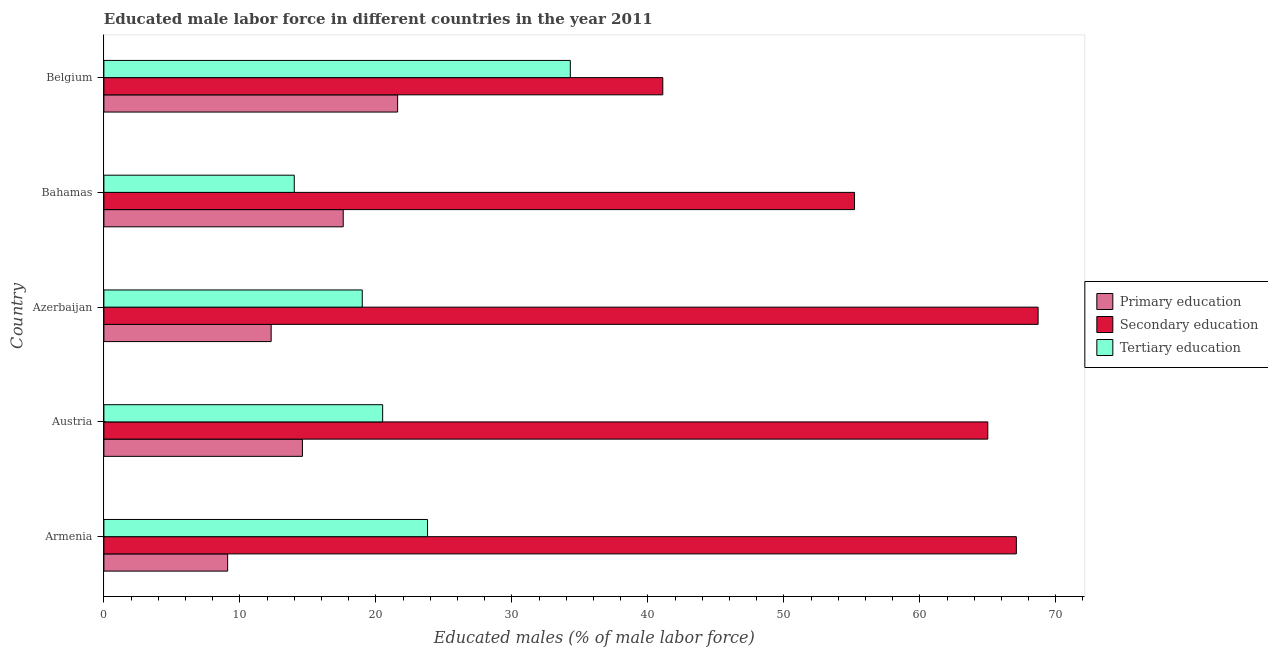How many different coloured bars are there?
Your answer should be very brief. 3. Are the number of bars on each tick of the Y-axis equal?
Ensure brevity in your answer.  Yes. How many bars are there on the 4th tick from the top?
Your response must be concise. 3. What is the label of the 4th group of bars from the top?
Offer a terse response. Austria. What is the percentage of male labor force who received primary education in Azerbaijan?
Offer a terse response. 12.3. Across all countries, what is the maximum percentage of male labor force who received primary education?
Provide a succinct answer. 21.6. Across all countries, what is the minimum percentage of male labor force who received tertiary education?
Offer a very short reply. 14. In which country was the percentage of male labor force who received secondary education minimum?
Offer a terse response. Belgium. What is the total percentage of male labor force who received tertiary education in the graph?
Your answer should be compact. 111.6. What is the difference between the percentage of male labor force who received secondary education in Bahamas and that in Belgium?
Make the answer very short. 14.1. What is the difference between the percentage of male labor force who received secondary education in Austria and the percentage of male labor force who received tertiary education in Armenia?
Keep it short and to the point. 41.2. What is the average percentage of male labor force who received primary education per country?
Ensure brevity in your answer.  15.04. What is the difference between the percentage of male labor force who received primary education and percentage of male labor force who received tertiary education in Austria?
Your answer should be compact. -5.9. What is the ratio of the percentage of male labor force who received primary education in Azerbaijan to that in Bahamas?
Offer a very short reply. 0.7. Is the difference between the percentage of male labor force who received secondary education in Austria and Belgium greater than the difference between the percentage of male labor force who received primary education in Austria and Belgium?
Offer a very short reply. Yes. What is the difference between the highest and the second highest percentage of male labor force who received primary education?
Provide a succinct answer. 4. What is the difference between the highest and the lowest percentage of male labor force who received primary education?
Ensure brevity in your answer.  12.5. In how many countries, is the percentage of male labor force who received tertiary education greater than the average percentage of male labor force who received tertiary education taken over all countries?
Ensure brevity in your answer.  2. Is the sum of the percentage of male labor force who received secondary education in Azerbaijan and Belgium greater than the maximum percentage of male labor force who received tertiary education across all countries?
Your answer should be compact. Yes. What does the 1st bar from the top in Azerbaijan represents?
Ensure brevity in your answer.  Tertiary education. What does the 3rd bar from the bottom in Armenia represents?
Give a very brief answer. Tertiary education. How many countries are there in the graph?
Your answer should be very brief. 5. Are the values on the major ticks of X-axis written in scientific E-notation?
Your response must be concise. No. Does the graph contain grids?
Your answer should be very brief. No. How many legend labels are there?
Provide a succinct answer. 3. What is the title of the graph?
Ensure brevity in your answer.  Educated male labor force in different countries in the year 2011. Does "Taxes on goods and services" appear as one of the legend labels in the graph?
Give a very brief answer. No. What is the label or title of the X-axis?
Offer a terse response. Educated males (% of male labor force). What is the label or title of the Y-axis?
Ensure brevity in your answer.  Country. What is the Educated males (% of male labor force) in Primary education in Armenia?
Offer a very short reply. 9.1. What is the Educated males (% of male labor force) of Secondary education in Armenia?
Offer a terse response. 67.1. What is the Educated males (% of male labor force) in Tertiary education in Armenia?
Your response must be concise. 23.8. What is the Educated males (% of male labor force) in Primary education in Austria?
Give a very brief answer. 14.6. What is the Educated males (% of male labor force) in Tertiary education in Austria?
Offer a terse response. 20.5. What is the Educated males (% of male labor force) of Primary education in Azerbaijan?
Offer a terse response. 12.3. What is the Educated males (% of male labor force) of Secondary education in Azerbaijan?
Ensure brevity in your answer.  68.7. What is the Educated males (% of male labor force) in Primary education in Bahamas?
Your answer should be compact. 17.6. What is the Educated males (% of male labor force) in Secondary education in Bahamas?
Make the answer very short. 55.2. What is the Educated males (% of male labor force) in Primary education in Belgium?
Give a very brief answer. 21.6. What is the Educated males (% of male labor force) of Secondary education in Belgium?
Make the answer very short. 41.1. What is the Educated males (% of male labor force) in Tertiary education in Belgium?
Provide a succinct answer. 34.3. Across all countries, what is the maximum Educated males (% of male labor force) of Primary education?
Offer a very short reply. 21.6. Across all countries, what is the maximum Educated males (% of male labor force) of Secondary education?
Your answer should be very brief. 68.7. Across all countries, what is the maximum Educated males (% of male labor force) in Tertiary education?
Your answer should be compact. 34.3. Across all countries, what is the minimum Educated males (% of male labor force) in Primary education?
Ensure brevity in your answer.  9.1. Across all countries, what is the minimum Educated males (% of male labor force) of Secondary education?
Provide a succinct answer. 41.1. Across all countries, what is the minimum Educated males (% of male labor force) in Tertiary education?
Your response must be concise. 14. What is the total Educated males (% of male labor force) in Primary education in the graph?
Your answer should be very brief. 75.2. What is the total Educated males (% of male labor force) in Secondary education in the graph?
Provide a short and direct response. 297.1. What is the total Educated males (% of male labor force) in Tertiary education in the graph?
Your answer should be very brief. 111.6. What is the difference between the Educated males (% of male labor force) of Secondary education in Armenia and that in Austria?
Your answer should be compact. 2.1. What is the difference between the Educated males (% of male labor force) of Tertiary education in Armenia and that in Austria?
Keep it short and to the point. 3.3. What is the difference between the Educated males (% of male labor force) in Primary education in Armenia and that in Azerbaijan?
Offer a very short reply. -3.2. What is the difference between the Educated males (% of male labor force) of Primary education in Armenia and that in Bahamas?
Provide a succinct answer. -8.5. What is the difference between the Educated males (% of male labor force) of Secondary education in Armenia and that in Bahamas?
Keep it short and to the point. 11.9. What is the difference between the Educated males (% of male labor force) of Primary education in Armenia and that in Belgium?
Keep it short and to the point. -12.5. What is the difference between the Educated males (% of male labor force) of Tertiary education in Armenia and that in Belgium?
Offer a terse response. -10.5. What is the difference between the Educated males (% of male labor force) in Tertiary education in Austria and that in Azerbaijan?
Give a very brief answer. 1.5. What is the difference between the Educated males (% of male labor force) in Primary education in Austria and that in Bahamas?
Offer a very short reply. -3. What is the difference between the Educated males (% of male labor force) in Secondary education in Austria and that in Bahamas?
Give a very brief answer. 9.8. What is the difference between the Educated males (% of male labor force) in Tertiary education in Austria and that in Bahamas?
Offer a very short reply. 6.5. What is the difference between the Educated males (% of male labor force) of Primary education in Austria and that in Belgium?
Give a very brief answer. -7. What is the difference between the Educated males (% of male labor force) of Secondary education in Austria and that in Belgium?
Ensure brevity in your answer.  23.9. What is the difference between the Educated males (% of male labor force) of Tertiary education in Austria and that in Belgium?
Offer a very short reply. -13.8. What is the difference between the Educated males (% of male labor force) of Primary education in Azerbaijan and that in Belgium?
Give a very brief answer. -9.3. What is the difference between the Educated males (% of male labor force) of Secondary education in Azerbaijan and that in Belgium?
Offer a terse response. 27.6. What is the difference between the Educated males (% of male labor force) of Tertiary education in Azerbaijan and that in Belgium?
Ensure brevity in your answer.  -15.3. What is the difference between the Educated males (% of male labor force) of Tertiary education in Bahamas and that in Belgium?
Provide a succinct answer. -20.3. What is the difference between the Educated males (% of male labor force) in Primary education in Armenia and the Educated males (% of male labor force) in Secondary education in Austria?
Ensure brevity in your answer.  -55.9. What is the difference between the Educated males (% of male labor force) of Primary education in Armenia and the Educated males (% of male labor force) of Tertiary education in Austria?
Make the answer very short. -11.4. What is the difference between the Educated males (% of male labor force) of Secondary education in Armenia and the Educated males (% of male labor force) of Tertiary education in Austria?
Provide a short and direct response. 46.6. What is the difference between the Educated males (% of male labor force) in Primary education in Armenia and the Educated males (% of male labor force) in Secondary education in Azerbaijan?
Offer a terse response. -59.6. What is the difference between the Educated males (% of male labor force) of Primary education in Armenia and the Educated males (% of male labor force) of Tertiary education in Azerbaijan?
Your answer should be very brief. -9.9. What is the difference between the Educated males (% of male labor force) in Secondary education in Armenia and the Educated males (% of male labor force) in Tertiary education in Azerbaijan?
Keep it short and to the point. 48.1. What is the difference between the Educated males (% of male labor force) in Primary education in Armenia and the Educated males (% of male labor force) in Secondary education in Bahamas?
Your response must be concise. -46.1. What is the difference between the Educated males (% of male labor force) of Primary education in Armenia and the Educated males (% of male labor force) of Tertiary education in Bahamas?
Ensure brevity in your answer.  -4.9. What is the difference between the Educated males (% of male labor force) of Secondary education in Armenia and the Educated males (% of male labor force) of Tertiary education in Bahamas?
Keep it short and to the point. 53.1. What is the difference between the Educated males (% of male labor force) of Primary education in Armenia and the Educated males (% of male labor force) of Secondary education in Belgium?
Ensure brevity in your answer.  -32. What is the difference between the Educated males (% of male labor force) of Primary education in Armenia and the Educated males (% of male labor force) of Tertiary education in Belgium?
Offer a terse response. -25.2. What is the difference between the Educated males (% of male labor force) of Secondary education in Armenia and the Educated males (% of male labor force) of Tertiary education in Belgium?
Your answer should be compact. 32.8. What is the difference between the Educated males (% of male labor force) in Primary education in Austria and the Educated males (% of male labor force) in Secondary education in Azerbaijan?
Provide a succinct answer. -54.1. What is the difference between the Educated males (% of male labor force) in Primary education in Austria and the Educated males (% of male labor force) in Tertiary education in Azerbaijan?
Your response must be concise. -4.4. What is the difference between the Educated males (% of male labor force) in Secondary education in Austria and the Educated males (% of male labor force) in Tertiary education in Azerbaijan?
Give a very brief answer. 46. What is the difference between the Educated males (% of male labor force) of Primary education in Austria and the Educated males (% of male labor force) of Secondary education in Bahamas?
Offer a very short reply. -40.6. What is the difference between the Educated males (% of male labor force) of Primary education in Austria and the Educated males (% of male labor force) of Secondary education in Belgium?
Provide a succinct answer. -26.5. What is the difference between the Educated males (% of male labor force) of Primary education in Austria and the Educated males (% of male labor force) of Tertiary education in Belgium?
Your answer should be very brief. -19.7. What is the difference between the Educated males (% of male labor force) of Secondary education in Austria and the Educated males (% of male labor force) of Tertiary education in Belgium?
Provide a succinct answer. 30.7. What is the difference between the Educated males (% of male labor force) of Primary education in Azerbaijan and the Educated males (% of male labor force) of Secondary education in Bahamas?
Provide a short and direct response. -42.9. What is the difference between the Educated males (% of male labor force) of Primary education in Azerbaijan and the Educated males (% of male labor force) of Tertiary education in Bahamas?
Keep it short and to the point. -1.7. What is the difference between the Educated males (% of male labor force) in Secondary education in Azerbaijan and the Educated males (% of male labor force) in Tertiary education in Bahamas?
Offer a very short reply. 54.7. What is the difference between the Educated males (% of male labor force) in Primary education in Azerbaijan and the Educated males (% of male labor force) in Secondary education in Belgium?
Offer a very short reply. -28.8. What is the difference between the Educated males (% of male labor force) in Secondary education in Azerbaijan and the Educated males (% of male labor force) in Tertiary education in Belgium?
Offer a very short reply. 34.4. What is the difference between the Educated males (% of male labor force) of Primary education in Bahamas and the Educated males (% of male labor force) of Secondary education in Belgium?
Your response must be concise. -23.5. What is the difference between the Educated males (% of male labor force) in Primary education in Bahamas and the Educated males (% of male labor force) in Tertiary education in Belgium?
Your response must be concise. -16.7. What is the difference between the Educated males (% of male labor force) in Secondary education in Bahamas and the Educated males (% of male labor force) in Tertiary education in Belgium?
Offer a very short reply. 20.9. What is the average Educated males (% of male labor force) of Primary education per country?
Provide a short and direct response. 15.04. What is the average Educated males (% of male labor force) in Secondary education per country?
Make the answer very short. 59.42. What is the average Educated males (% of male labor force) of Tertiary education per country?
Offer a very short reply. 22.32. What is the difference between the Educated males (% of male labor force) of Primary education and Educated males (% of male labor force) of Secondary education in Armenia?
Keep it short and to the point. -58. What is the difference between the Educated males (% of male labor force) in Primary education and Educated males (% of male labor force) in Tertiary education in Armenia?
Provide a short and direct response. -14.7. What is the difference between the Educated males (% of male labor force) of Secondary education and Educated males (% of male labor force) of Tertiary education in Armenia?
Keep it short and to the point. 43.3. What is the difference between the Educated males (% of male labor force) in Primary education and Educated males (% of male labor force) in Secondary education in Austria?
Ensure brevity in your answer.  -50.4. What is the difference between the Educated males (% of male labor force) of Secondary education and Educated males (% of male labor force) of Tertiary education in Austria?
Your answer should be very brief. 44.5. What is the difference between the Educated males (% of male labor force) in Primary education and Educated males (% of male labor force) in Secondary education in Azerbaijan?
Your answer should be very brief. -56.4. What is the difference between the Educated males (% of male labor force) of Primary education and Educated males (% of male labor force) of Tertiary education in Azerbaijan?
Ensure brevity in your answer.  -6.7. What is the difference between the Educated males (% of male labor force) of Secondary education and Educated males (% of male labor force) of Tertiary education in Azerbaijan?
Offer a terse response. 49.7. What is the difference between the Educated males (% of male labor force) in Primary education and Educated males (% of male labor force) in Secondary education in Bahamas?
Provide a short and direct response. -37.6. What is the difference between the Educated males (% of male labor force) in Secondary education and Educated males (% of male labor force) in Tertiary education in Bahamas?
Give a very brief answer. 41.2. What is the difference between the Educated males (% of male labor force) in Primary education and Educated males (% of male labor force) in Secondary education in Belgium?
Keep it short and to the point. -19.5. What is the ratio of the Educated males (% of male labor force) of Primary education in Armenia to that in Austria?
Give a very brief answer. 0.62. What is the ratio of the Educated males (% of male labor force) in Secondary education in Armenia to that in Austria?
Keep it short and to the point. 1.03. What is the ratio of the Educated males (% of male labor force) of Tertiary education in Armenia to that in Austria?
Offer a very short reply. 1.16. What is the ratio of the Educated males (% of male labor force) of Primary education in Armenia to that in Azerbaijan?
Your answer should be compact. 0.74. What is the ratio of the Educated males (% of male labor force) in Secondary education in Armenia to that in Azerbaijan?
Ensure brevity in your answer.  0.98. What is the ratio of the Educated males (% of male labor force) of Tertiary education in Armenia to that in Azerbaijan?
Your answer should be very brief. 1.25. What is the ratio of the Educated males (% of male labor force) in Primary education in Armenia to that in Bahamas?
Give a very brief answer. 0.52. What is the ratio of the Educated males (% of male labor force) of Secondary education in Armenia to that in Bahamas?
Keep it short and to the point. 1.22. What is the ratio of the Educated males (% of male labor force) of Primary education in Armenia to that in Belgium?
Give a very brief answer. 0.42. What is the ratio of the Educated males (% of male labor force) in Secondary education in Armenia to that in Belgium?
Make the answer very short. 1.63. What is the ratio of the Educated males (% of male labor force) of Tertiary education in Armenia to that in Belgium?
Your answer should be very brief. 0.69. What is the ratio of the Educated males (% of male labor force) in Primary education in Austria to that in Azerbaijan?
Offer a terse response. 1.19. What is the ratio of the Educated males (% of male labor force) of Secondary education in Austria to that in Azerbaijan?
Your response must be concise. 0.95. What is the ratio of the Educated males (% of male labor force) in Tertiary education in Austria to that in Azerbaijan?
Provide a succinct answer. 1.08. What is the ratio of the Educated males (% of male labor force) of Primary education in Austria to that in Bahamas?
Provide a short and direct response. 0.83. What is the ratio of the Educated males (% of male labor force) in Secondary education in Austria to that in Bahamas?
Ensure brevity in your answer.  1.18. What is the ratio of the Educated males (% of male labor force) of Tertiary education in Austria to that in Bahamas?
Provide a short and direct response. 1.46. What is the ratio of the Educated males (% of male labor force) in Primary education in Austria to that in Belgium?
Your response must be concise. 0.68. What is the ratio of the Educated males (% of male labor force) of Secondary education in Austria to that in Belgium?
Keep it short and to the point. 1.58. What is the ratio of the Educated males (% of male labor force) of Tertiary education in Austria to that in Belgium?
Offer a terse response. 0.6. What is the ratio of the Educated males (% of male labor force) of Primary education in Azerbaijan to that in Bahamas?
Ensure brevity in your answer.  0.7. What is the ratio of the Educated males (% of male labor force) in Secondary education in Azerbaijan to that in Bahamas?
Offer a terse response. 1.24. What is the ratio of the Educated males (% of male labor force) in Tertiary education in Azerbaijan to that in Bahamas?
Make the answer very short. 1.36. What is the ratio of the Educated males (% of male labor force) in Primary education in Azerbaijan to that in Belgium?
Give a very brief answer. 0.57. What is the ratio of the Educated males (% of male labor force) in Secondary education in Azerbaijan to that in Belgium?
Ensure brevity in your answer.  1.67. What is the ratio of the Educated males (% of male labor force) in Tertiary education in Azerbaijan to that in Belgium?
Make the answer very short. 0.55. What is the ratio of the Educated males (% of male labor force) of Primary education in Bahamas to that in Belgium?
Give a very brief answer. 0.81. What is the ratio of the Educated males (% of male labor force) of Secondary education in Bahamas to that in Belgium?
Offer a terse response. 1.34. What is the ratio of the Educated males (% of male labor force) in Tertiary education in Bahamas to that in Belgium?
Keep it short and to the point. 0.41. What is the difference between the highest and the second highest Educated males (% of male labor force) in Primary education?
Offer a terse response. 4. What is the difference between the highest and the second highest Educated males (% of male labor force) in Secondary education?
Ensure brevity in your answer.  1.6. What is the difference between the highest and the lowest Educated males (% of male labor force) in Primary education?
Your response must be concise. 12.5. What is the difference between the highest and the lowest Educated males (% of male labor force) in Secondary education?
Your answer should be very brief. 27.6. What is the difference between the highest and the lowest Educated males (% of male labor force) in Tertiary education?
Your response must be concise. 20.3. 